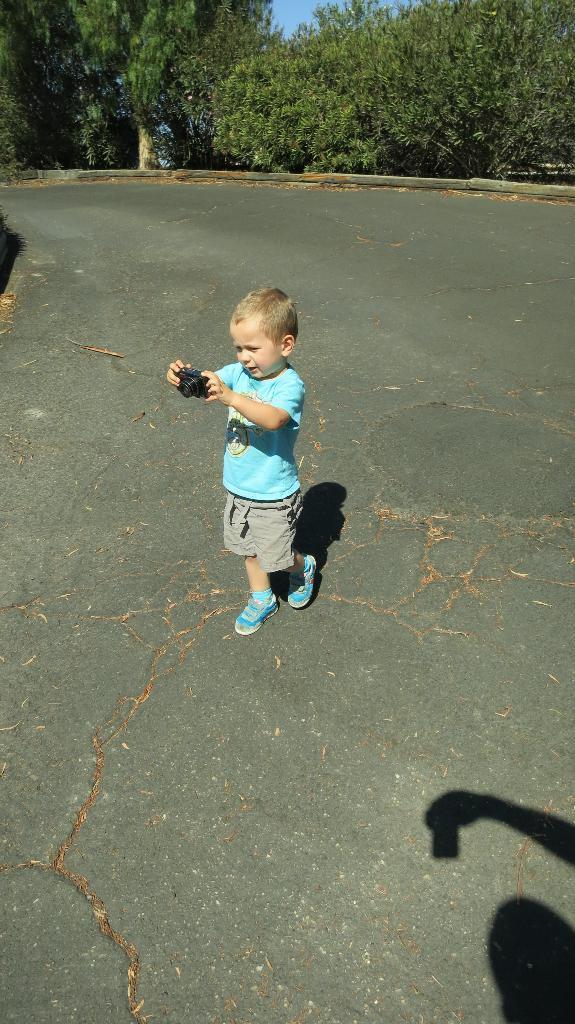Describe this image in one or two sentences. In this picture I can see a boy standing and holding a camera, there is a shadow of another person holding an object, and in the background there are trees and sky. 